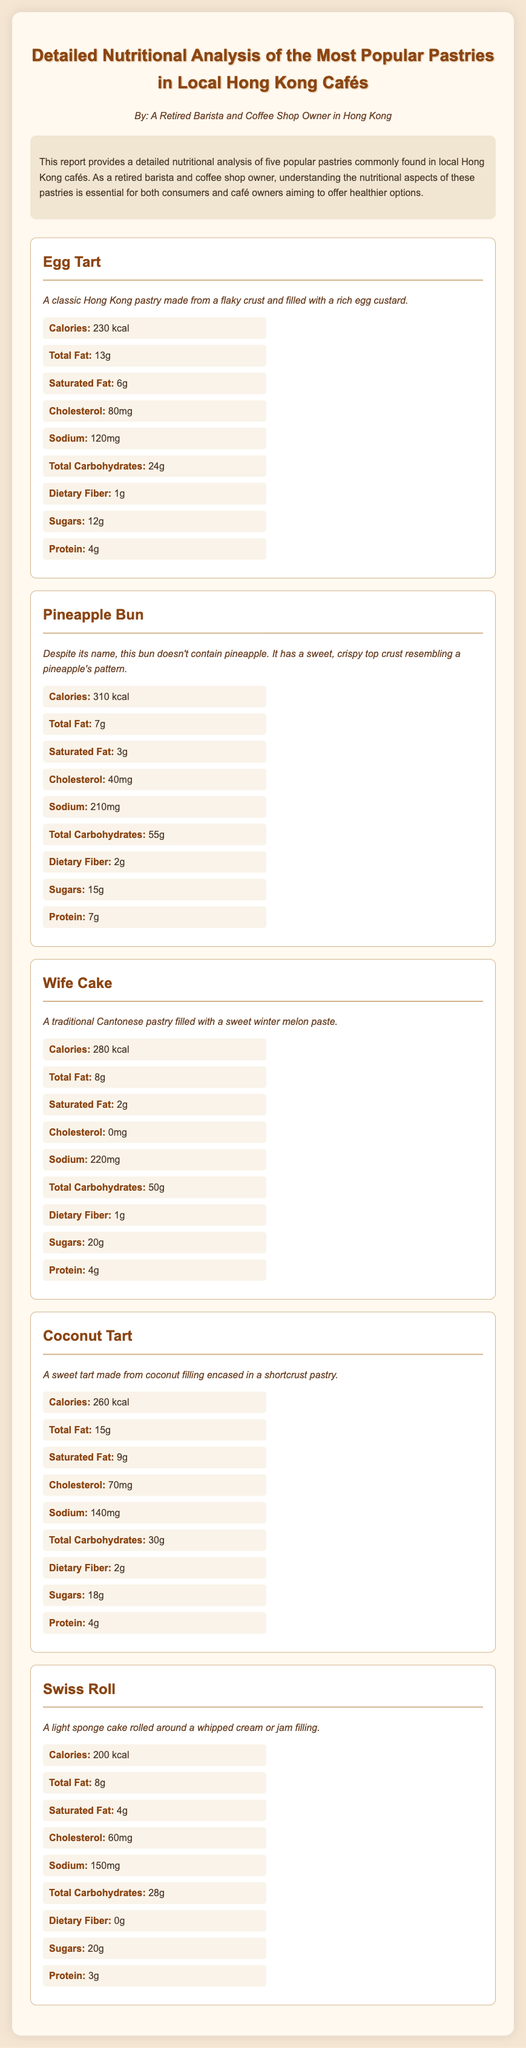What is the calorie count of an Egg Tart? The calorie count for an Egg Tart is provided directly in the nutritional values section.
Answer: 230 kcal Which pastry has the highest total carbohydrates? The total carbohydrates for each pastry can be compared, and the highest value is identified.
Answer: Pineapple Bun How many grams of saturated fat are in a Coconut Tart? The saturated fat content for a Coconut Tart is specified in the nutritional values section.
Answer: 9g What is the cholesterol content of a Wife Cake? The cholesterol content is explicitly mentioned in the nutritional values section for a Wife Cake.
Answer: 0mg Which pastry has the least amount of protein? By comparing the protein values in the nutritional values section, the pastry with the least protein can be determined.
Answer: Swiss Roll What is the description of a Pineapple Bun? The description provided in the document gives insight into the characteristics of a Pineapple Bun.
Answer: Despite its name, this bun doesn't contain pineapple. It has a sweet, crispy top crust resembling a pineapple's pattern Which pastry contains the highest amount of sugars? The sugar content of each pastry is to be compared to find which one has the highest amount.
Answer: Wife Cake What is the overall purpose of this lab report? The introduction section outlines the purpose of the report, explaining what it aims to achieve.
Answer: Understanding the nutritional aspects of these pastries How many grams of dietary fiber are in a Swiss Roll? The dietary fiber content is listed under the nutritional values specifically for the Swiss Roll.
Answer: 0g 